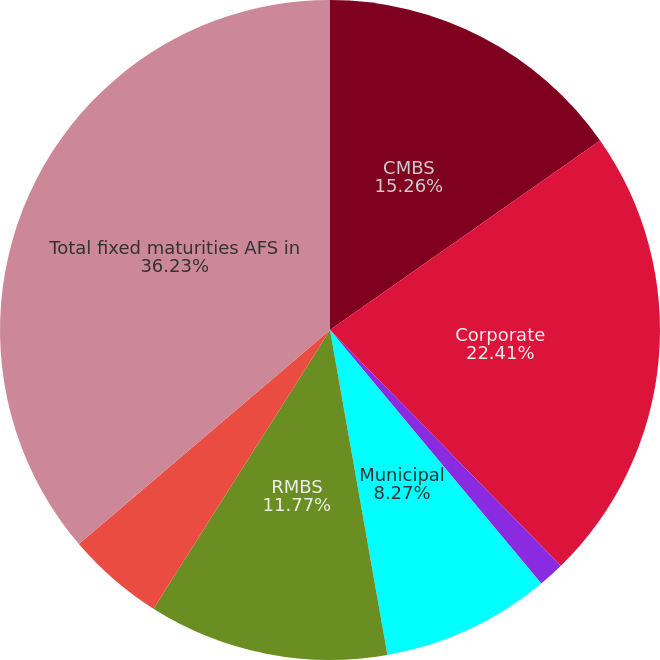Convert chart to OTSL. <chart><loc_0><loc_0><loc_500><loc_500><pie_chart><fcel>CMBS<fcel>Corporate<fcel>Foreign govt/govt agencies<fcel>Municipal<fcel>RMBS<fcel>US Treasuries<fcel>Total fixed maturities AFS in<nl><fcel>15.26%<fcel>22.41%<fcel>1.28%<fcel>8.27%<fcel>11.77%<fcel>4.78%<fcel>36.24%<nl></chart> 